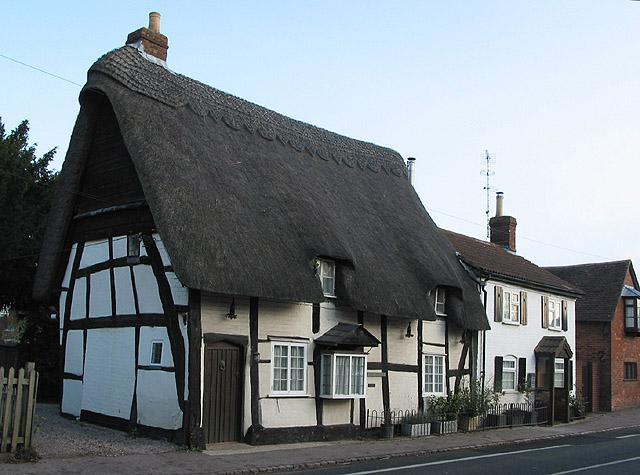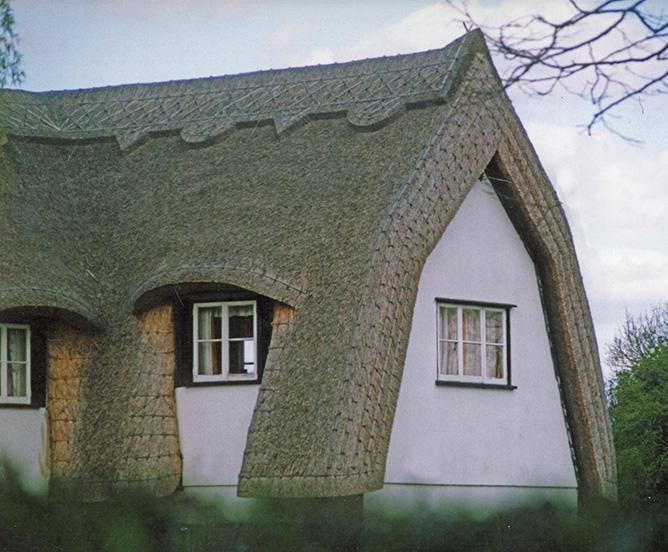The first image is the image on the left, the second image is the image on the right. For the images shown, is this caption "The left image shows the front of a white house with bold dark lines on it forming geometric patterns, a chimney on the left end, and a thick gray peaked roof with at least one notched cut-out for windows." true? Answer yes or no. Yes. The first image is the image on the left, the second image is the image on the right. Examine the images to the left and right. Is the description "There is a fence bordering the house in one of the images." accurate? Answer yes or no. No. 